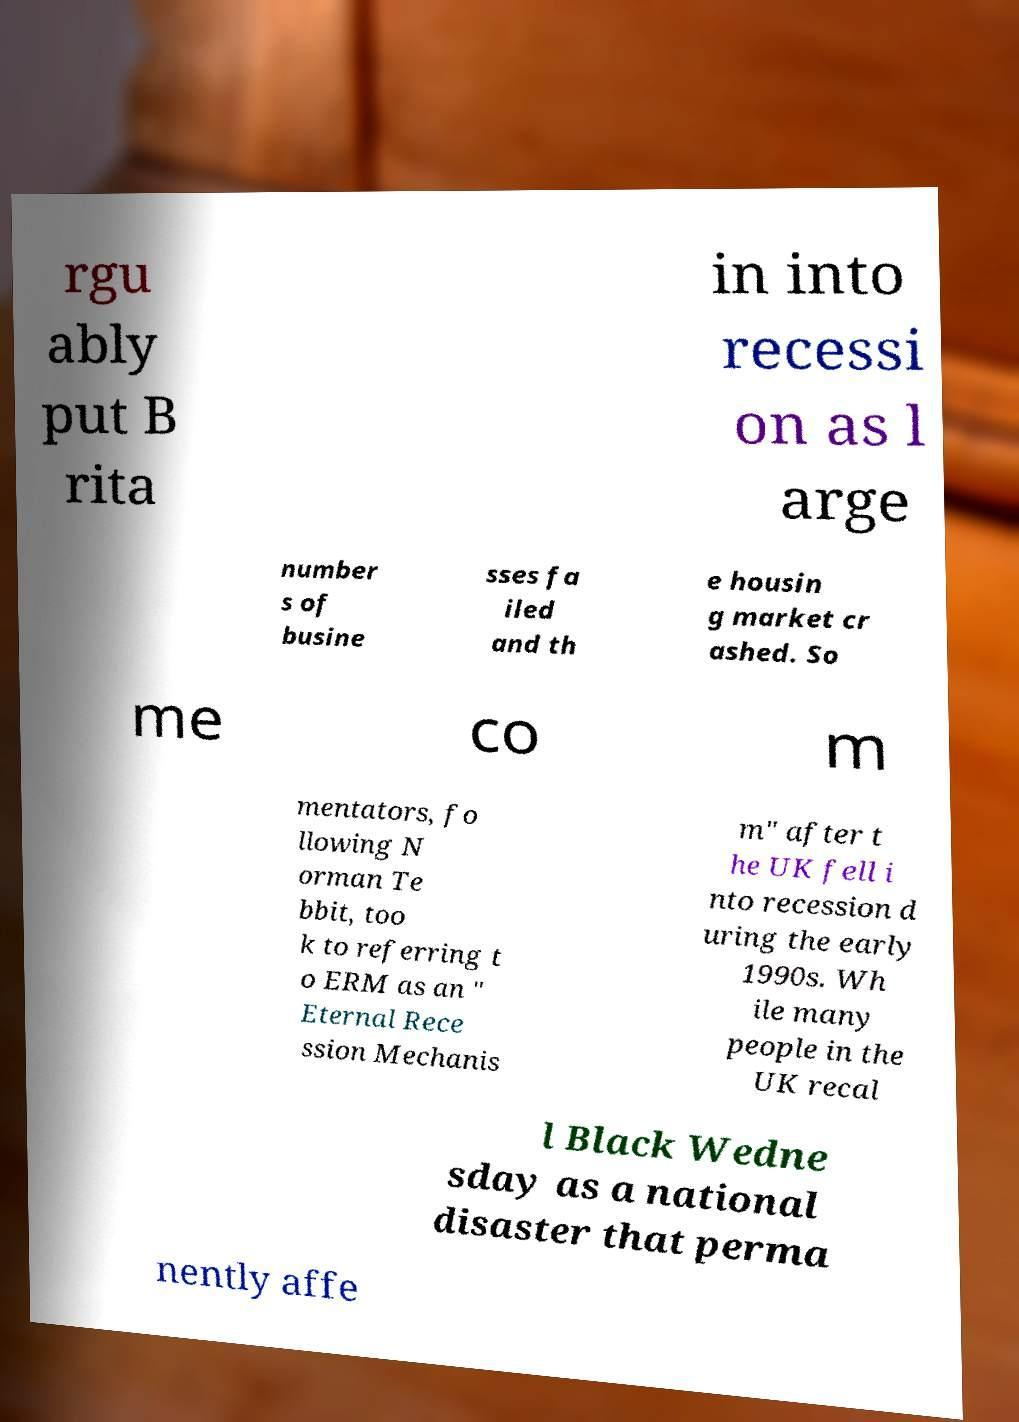Could you assist in decoding the text presented in this image and type it out clearly? rgu ably put B rita in into recessi on as l arge number s of busine sses fa iled and th e housin g market cr ashed. So me co m mentators, fo llowing N orman Te bbit, too k to referring t o ERM as an " Eternal Rece ssion Mechanis m" after t he UK fell i nto recession d uring the early 1990s. Wh ile many people in the UK recal l Black Wedne sday as a national disaster that perma nently affe 